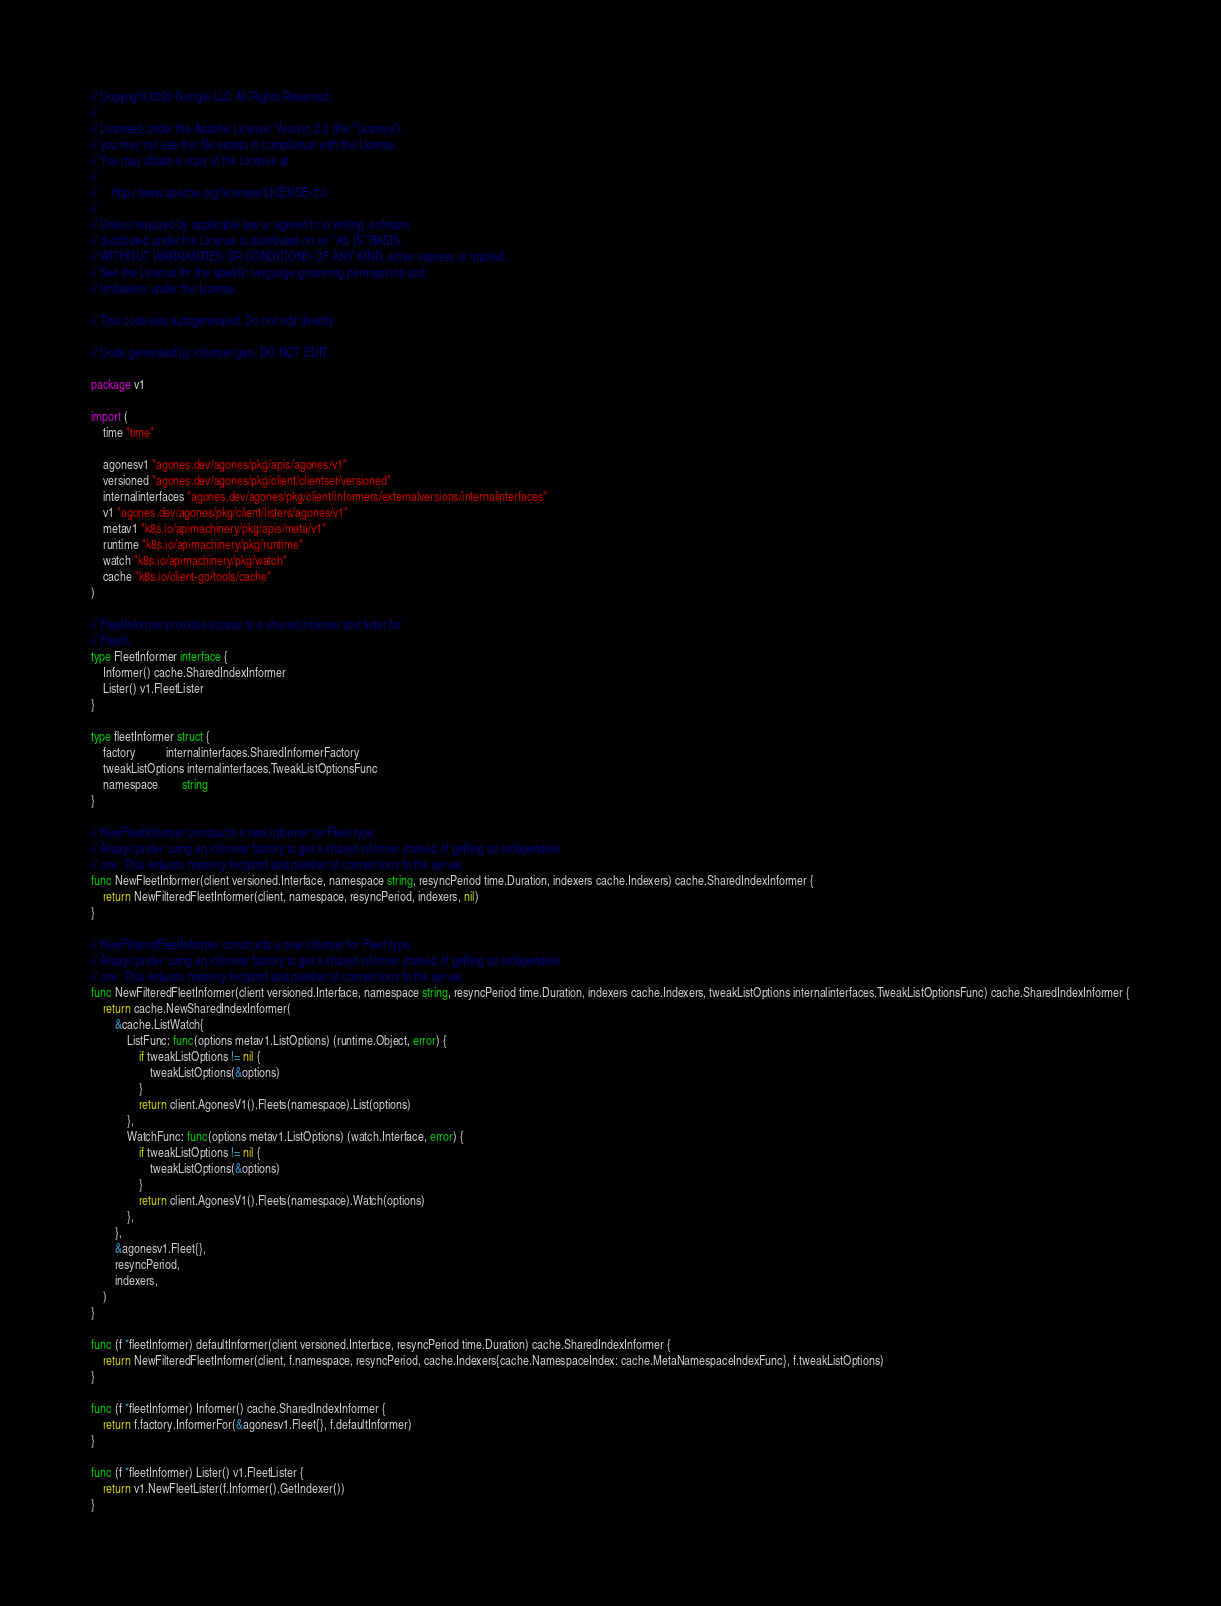<code> <loc_0><loc_0><loc_500><loc_500><_Go_>// Copyright 2020 Google LLC All Rights Reserved.
//
// Licensed under the Apache License, Version 2.0 (the "License");
// you may not use this file except in compliance with the License.
// You may obtain a copy of the License at
//
//     http://www.apache.org/licenses/LICENSE-2.0
//
// Unless required by applicable law or agreed to in writing, software
// distributed under the License is distributed on an "AS IS" BASIS,
// WITHOUT WARRANTIES OR CONDITIONS OF ANY KIND, either express or implied.
// See the License for the specific language governing permissions and
// limitations under the License.

// This code was autogenerated. Do not edit directly.

// Code generated by informer-gen. DO NOT EDIT.

package v1

import (
	time "time"

	agonesv1 "agones.dev/agones/pkg/apis/agones/v1"
	versioned "agones.dev/agones/pkg/client/clientset/versioned"
	internalinterfaces "agones.dev/agones/pkg/client/informers/externalversions/internalinterfaces"
	v1 "agones.dev/agones/pkg/client/listers/agones/v1"
	metav1 "k8s.io/apimachinery/pkg/apis/meta/v1"
	runtime "k8s.io/apimachinery/pkg/runtime"
	watch "k8s.io/apimachinery/pkg/watch"
	cache "k8s.io/client-go/tools/cache"
)

// FleetInformer provides access to a shared informer and lister for
// Fleets.
type FleetInformer interface {
	Informer() cache.SharedIndexInformer
	Lister() v1.FleetLister
}

type fleetInformer struct {
	factory          internalinterfaces.SharedInformerFactory
	tweakListOptions internalinterfaces.TweakListOptionsFunc
	namespace        string
}

// NewFleetInformer constructs a new informer for Fleet type.
// Always prefer using an informer factory to get a shared informer instead of getting an independent
// one. This reduces memory footprint and number of connections to the server.
func NewFleetInformer(client versioned.Interface, namespace string, resyncPeriod time.Duration, indexers cache.Indexers) cache.SharedIndexInformer {
	return NewFilteredFleetInformer(client, namespace, resyncPeriod, indexers, nil)
}

// NewFilteredFleetInformer constructs a new informer for Fleet type.
// Always prefer using an informer factory to get a shared informer instead of getting an independent
// one. This reduces memory footprint and number of connections to the server.
func NewFilteredFleetInformer(client versioned.Interface, namespace string, resyncPeriod time.Duration, indexers cache.Indexers, tweakListOptions internalinterfaces.TweakListOptionsFunc) cache.SharedIndexInformer {
	return cache.NewSharedIndexInformer(
		&cache.ListWatch{
			ListFunc: func(options metav1.ListOptions) (runtime.Object, error) {
				if tweakListOptions != nil {
					tweakListOptions(&options)
				}
				return client.AgonesV1().Fleets(namespace).List(options)
			},
			WatchFunc: func(options metav1.ListOptions) (watch.Interface, error) {
				if tweakListOptions != nil {
					tweakListOptions(&options)
				}
				return client.AgonesV1().Fleets(namespace).Watch(options)
			},
		},
		&agonesv1.Fleet{},
		resyncPeriod,
		indexers,
	)
}

func (f *fleetInformer) defaultInformer(client versioned.Interface, resyncPeriod time.Duration) cache.SharedIndexInformer {
	return NewFilteredFleetInformer(client, f.namespace, resyncPeriod, cache.Indexers{cache.NamespaceIndex: cache.MetaNamespaceIndexFunc}, f.tweakListOptions)
}

func (f *fleetInformer) Informer() cache.SharedIndexInformer {
	return f.factory.InformerFor(&agonesv1.Fleet{}, f.defaultInformer)
}

func (f *fleetInformer) Lister() v1.FleetLister {
	return v1.NewFleetLister(f.Informer().GetIndexer())
}
</code> 